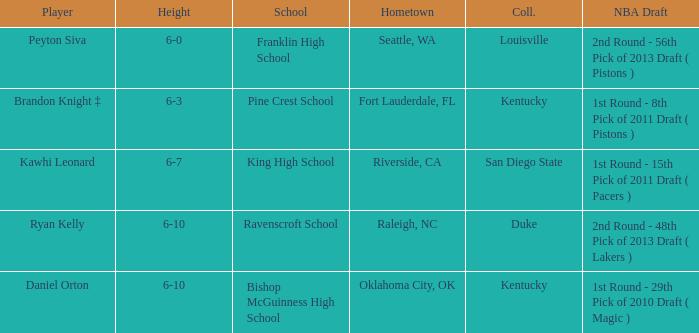Which school is in Riverside, CA? King High School. 